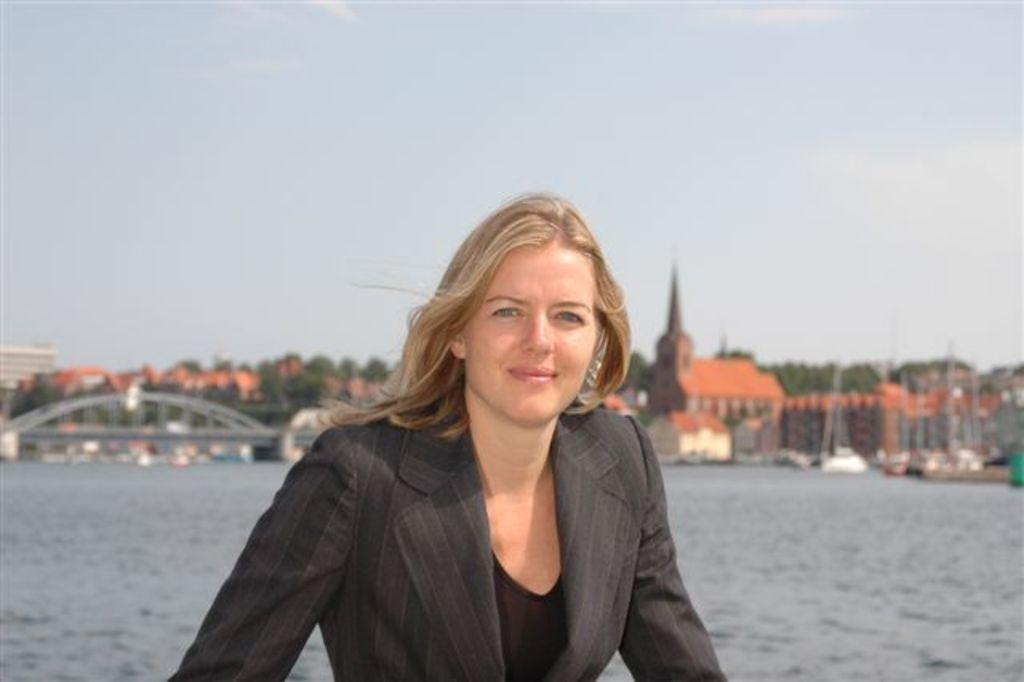What is the main subject of the image? There is a woman standing in the middle of the image. What is the woman's expression in the image? The woman is smiling in the image. What can be seen behind the woman? There is water visible behind the woman. What is visible in the background of the image? There are buildings and trees in the background of the image. What is visible at the top of the image? Clouds and the sky are visible at the top of the image. Who is the owner of the thumb visible in the image? There is no thumb visible in the image. What type of cable is being used by the woman in the image? There is no cable present in the image. 